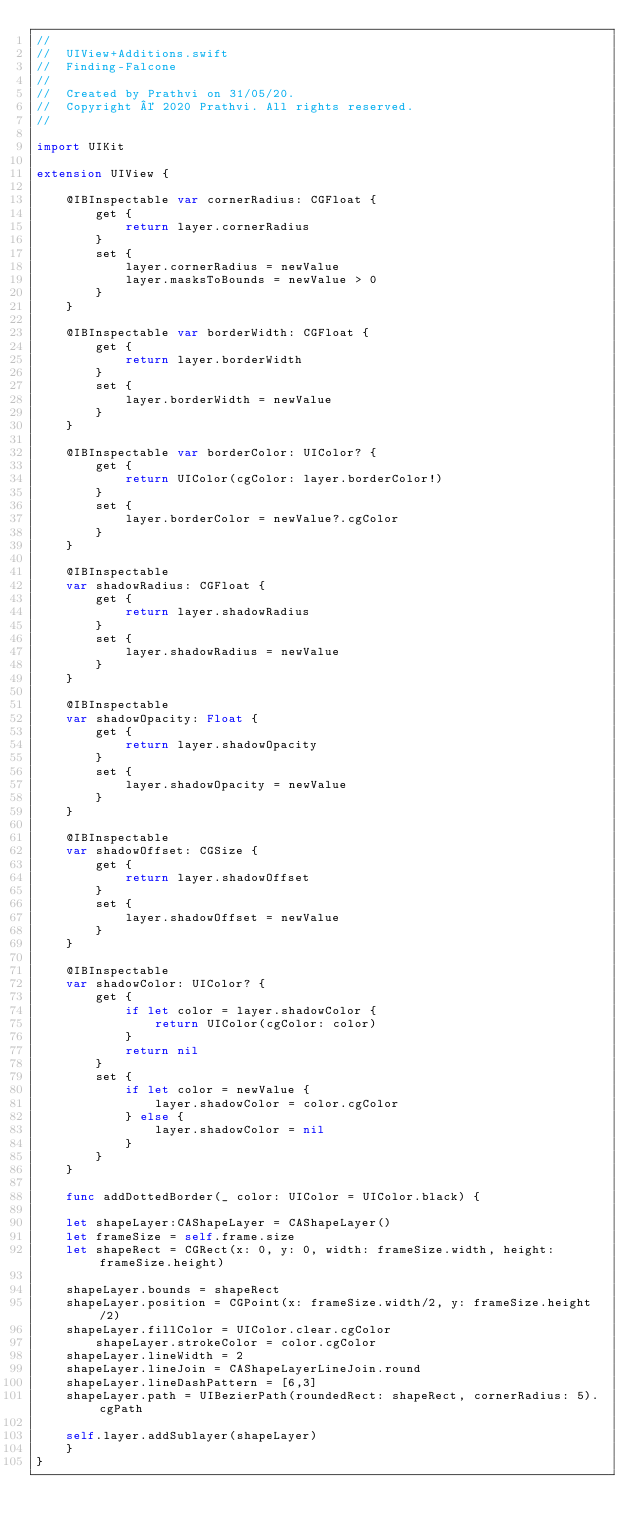<code> <loc_0><loc_0><loc_500><loc_500><_Swift_>//
//  UIView+Additions.swift
//  Finding-Falcone
//
//  Created by Prathvi on 31/05/20.
//  Copyright © 2020 Prathvi. All rights reserved.
//

import UIKit

extension UIView {

    @IBInspectable var cornerRadius: CGFloat {
        get {
            return layer.cornerRadius
        }
        set {
            layer.cornerRadius = newValue
            layer.masksToBounds = newValue > 0
        }
    }

    @IBInspectable var borderWidth: CGFloat {
        get {
            return layer.borderWidth
        }
        set {
            layer.borderWidth = newValue
        }
    }

    @IBInspectable var borderColor: UIColor? {
        get {
            return UIColor(cgColor: layer.borderColor!)
        }
        set {
            layer.borderColor = newValue?.cgColor
        }
    }

    @IBInspectable
    var shadowRadius: CGFloat {
        get {
            return layer.shadowRadius
        }
        set {
            layer.shadowRadius = newValue
        }
    }

    @IBInspectable
    var shadowOpacity: Float {
        get {
            return layer.shadowOpacity
        }
        set {
            layer.shadowOpacity = newValue
        }
    }

    @IBInspectable
    var shadowOffset: CGSize {
        get {
            return layer.shadowOffset
        }
        set {
            layer.shadowOffset = newValue
        }
    }

    @IBInspectable
    var shadowColor: UIColor? {
        get {
            if let color = layer.shadowColor {
                return UIColor(cgColor: color)
            }
            return nil
        }
        set {
            if let color = newValue {
                layer.shadowColor = color.cgColor
            } else {
                layer.shadowColor = nil
            }
        }
    }

    func addDottedBorder(_ color: UIColor = UIColor.black) {

    let shapeLayer:CAShapeLayer = CAShapeLayer()
    let frameSize = self.frame.size
    let shapeRect = CGRect(x: 0, y: 0, width: frameSize.width, height: frameSize.height)

    shapeLayer.bounds = shapeRect
    shapeLayer.position = CGPoint(x: frameSize.width/2, y: frameSize.height/2)
    shapeLayer.fillColor = UIColor.clear.cgColor
        shapeLayer.strokeColor = color.cgColor
    shapeLayer.lineWidth = 2
    shapeLayer.lineJoin = CAShapeLayerLineJoin.round
    shapeLayer.lineDashPattern = [6,3]
    shapeLayer.path = UIBezierPath(roundedRect: shapeRect, cornerRadius: 5).cgPath

    self.layer.addSublayer(shapeLayer)
    }
}
</code> 